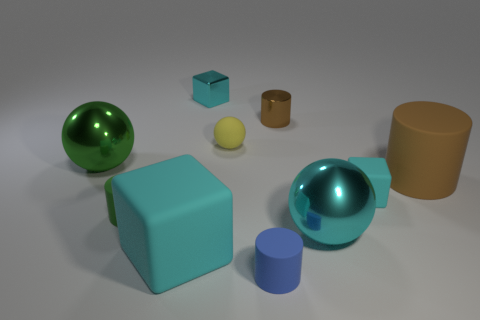The cyan thing that is behind the tiny green matte cylinder and in front of the cyan metal block has what shape? cube 